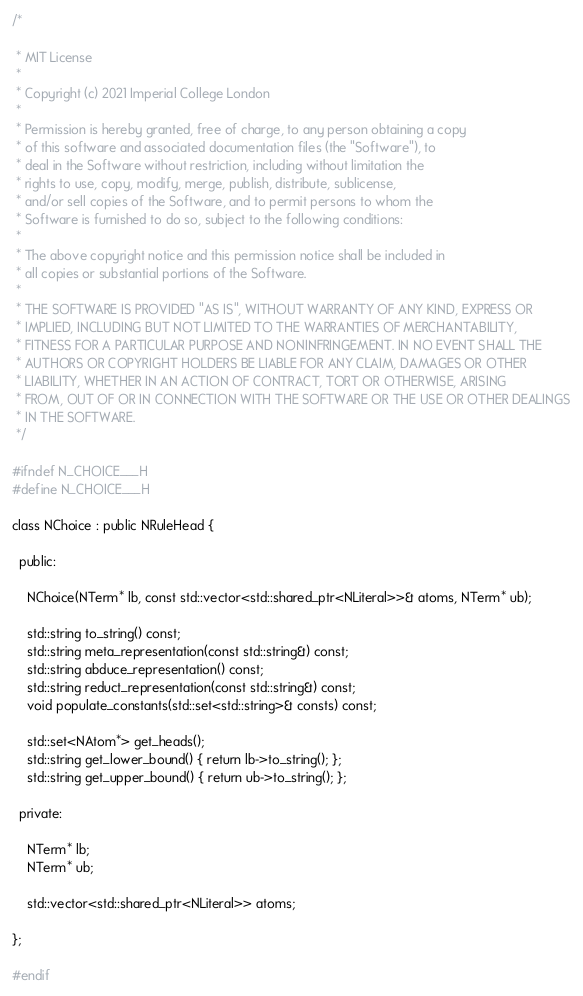Convert code to text. <code><loc_0><loc_0><loc_500><loc_500><_C_>/*

 * MIT License
 *
 * Copyright (c) 2021 Imperial College London
 *
 * Permission is hereby granted, free of charge, to any person obtaining a copy
 * of this software and associated documentation files (the "Software"), to
 * deal in the Software without restriction, including without limitation the
 * rights to use, copy, modify, merge, publish, distribute, sublicense,
 * and/or sell copies of the Software, and to permit persons to whom the
 * Software is furnished to do so, subject to the following conditions:
 *
 * The above copyright notice and this permission notice shall be included in
 * all copies or substantial portions of the Software.
 *
 * THE SOFTWARE IS PROVIDED "AS IS", WITHOUT WARRANTY OF ANY KIND, EXPRESS OR
 * IMPLIED, INCLUDING BUT NOT LIMITED TO THE WARRANTIES OF MERCHANTABILITY,
 * FITNESS FOR A PARTICULAR PURPOSE AND NONINFRINGEMENT. IN NO EVENT SHALL THE
 * AUTHORS OR COPYRIGHT HOLDERS BE LIABLE FOR ANY CLAIM, DAMAGES OR OTHER
 * LIABILITY, WHETHER IN AN ACTION OF CONTRACT, TORT OR OTHERWISE, ARISING
 * FROM, OUT OF OR IN CONNECTION WITH THE SOFTWARE OR THE USE OR OTHER DEALINGS
 * IN THE SOFTWARE.
 */

#ifndef N_CHOICE___H
#define N_CHOICE___H

class NChoice : public NRuleHead {

  public:

    NChoice(NTerm* lb, const std::vector<std::shared_ptr<NLiteral>>& atoms, NTerm* ub);

    std::string to_string() const;
    std::string meta_representation(const std::string&) const;
    std::string abduce_representation() const;
    std::string reduct_representation(const std::string&) const;
    void populate_constants(std::set<std::string>& consts) const;

    std::set<NAtom*> get_heads();
    std::string get_lower_bound() { return lb->to_string(); };
    std::string get_upper_bound() { return ub->to_string(); };

  private:

    NTerm* lb;
    NTerm* ub;

    std::vector<std::shared_ptr<NLiteral>> atoms;

};

#endif
</code> 